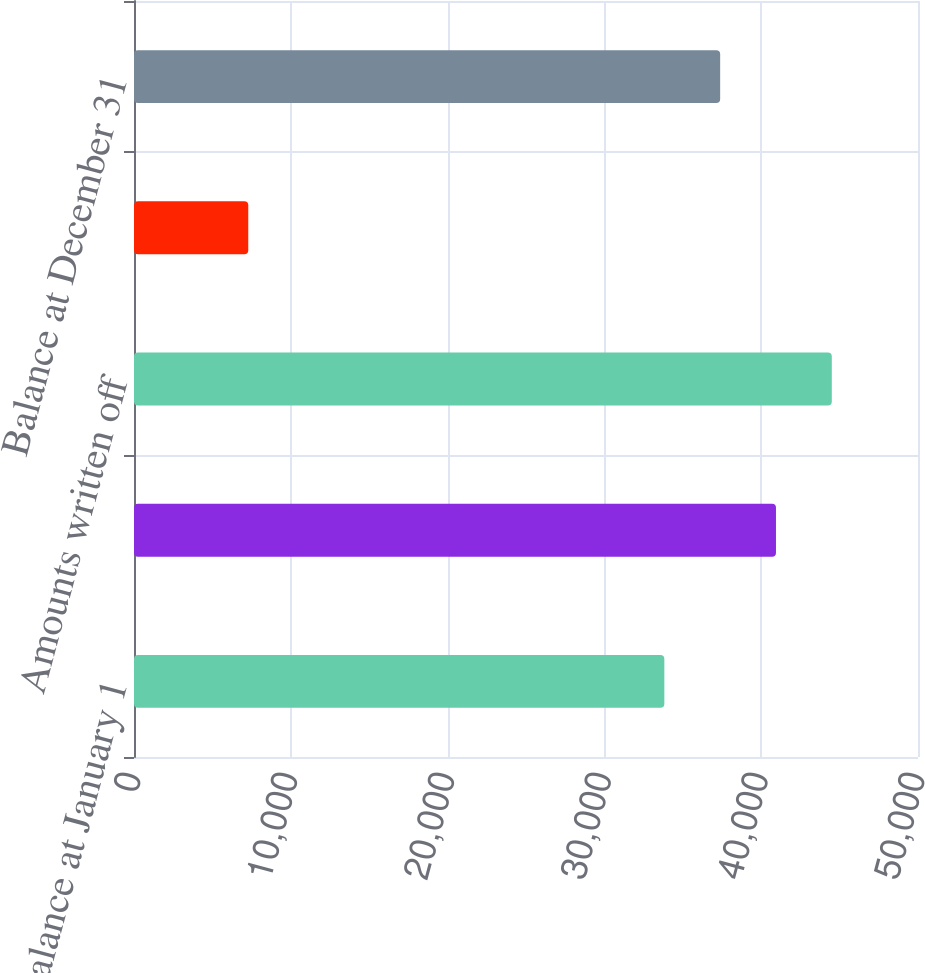Convert chart to OTSL. <chart><loc_0><loc_0><loc_500><loc_500><bar_chart><fcel>Balance at January 1<fcel>Amounts charged to expense<fcel>Amounts written off<fcel>Recoveries of amounts written<fcel>Balance at December 31<nl><fcel>33823<fcel>40942.8<fcel>44502.7<fcel>7287<fcel>37382.9<nl></chart> 